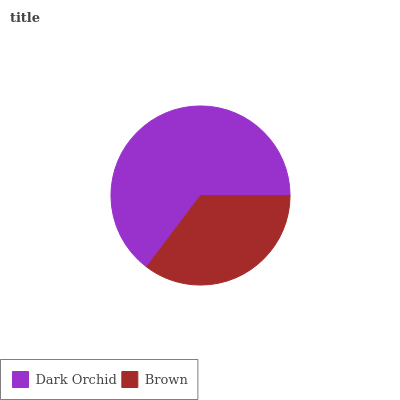Is Brown the minimum?
Answer yes or no. Yes. Is Dark Orchid the maximum?
Answer yes or no. Yes. Is Brown the maximum?
Answer yes or no. No. Is Dark Orchid greater than Brown?
Answer yes or no. Yes. Is Brown less than Dark Orchid?
Answer yes or no. Yes. Is Brown greater than Dark Orchid?
Answer yes or no. No. Is Dark Orchid less than Brown?
Answer yes or no. No. Is Dark Orchid the high median?
Answer yes or no. Yes. Is Brown the low median?
Answer yes or no. Yes. Is Brown the high median?
Answer yes or no. No. Is Dark Orchid the low median?
Answer yes or no. No. 